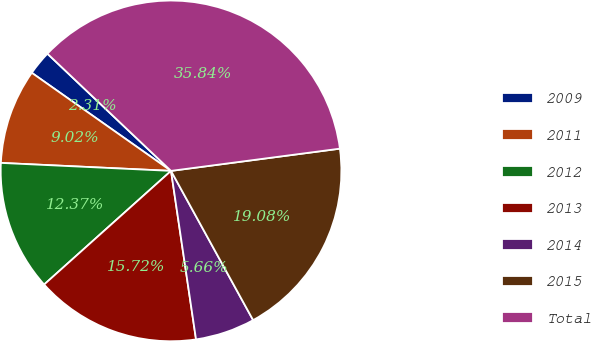<chart> <loc_0><loc_0><loc_500><loc_500><pie_chart><fcel>2009<fcel>2011<fcel>2012<fcel>2013<fcel>2014<fcel>2015<fcel>Total<nl><fcel>2.31%<fcel>9.02%<fcel>12.37%<fcel>15.72%<fcel>5.66%<fcel>19.08%<fcel>35.84%<nl></chart> 